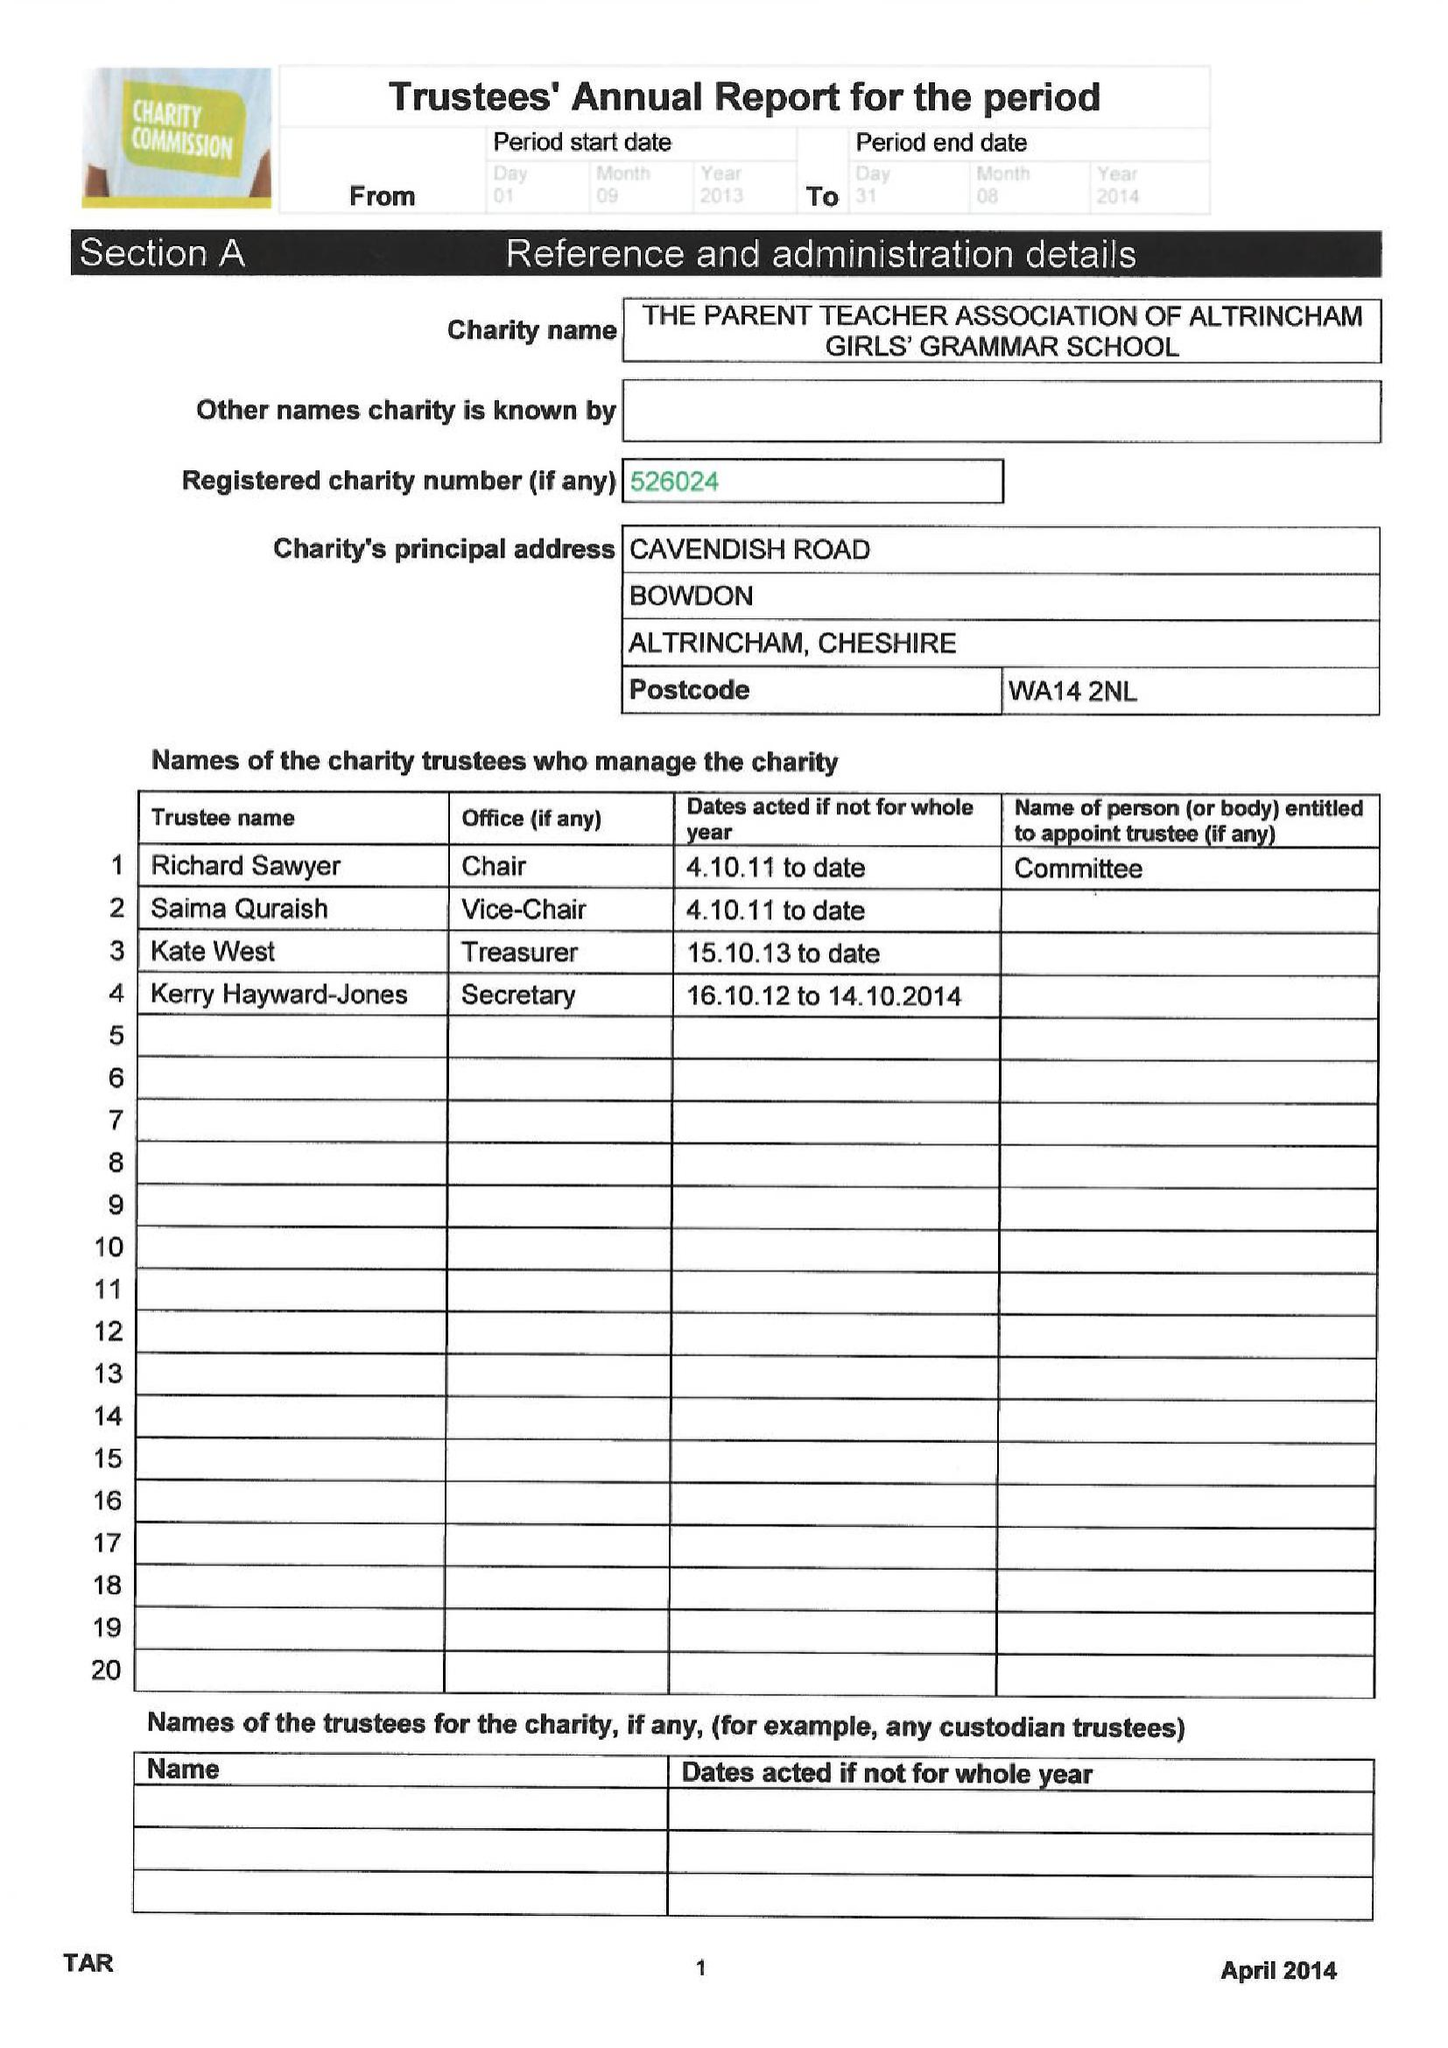What is the value for the address__street_line?
Answer the question using a single word or phrase. CAVENDISH ROAD 